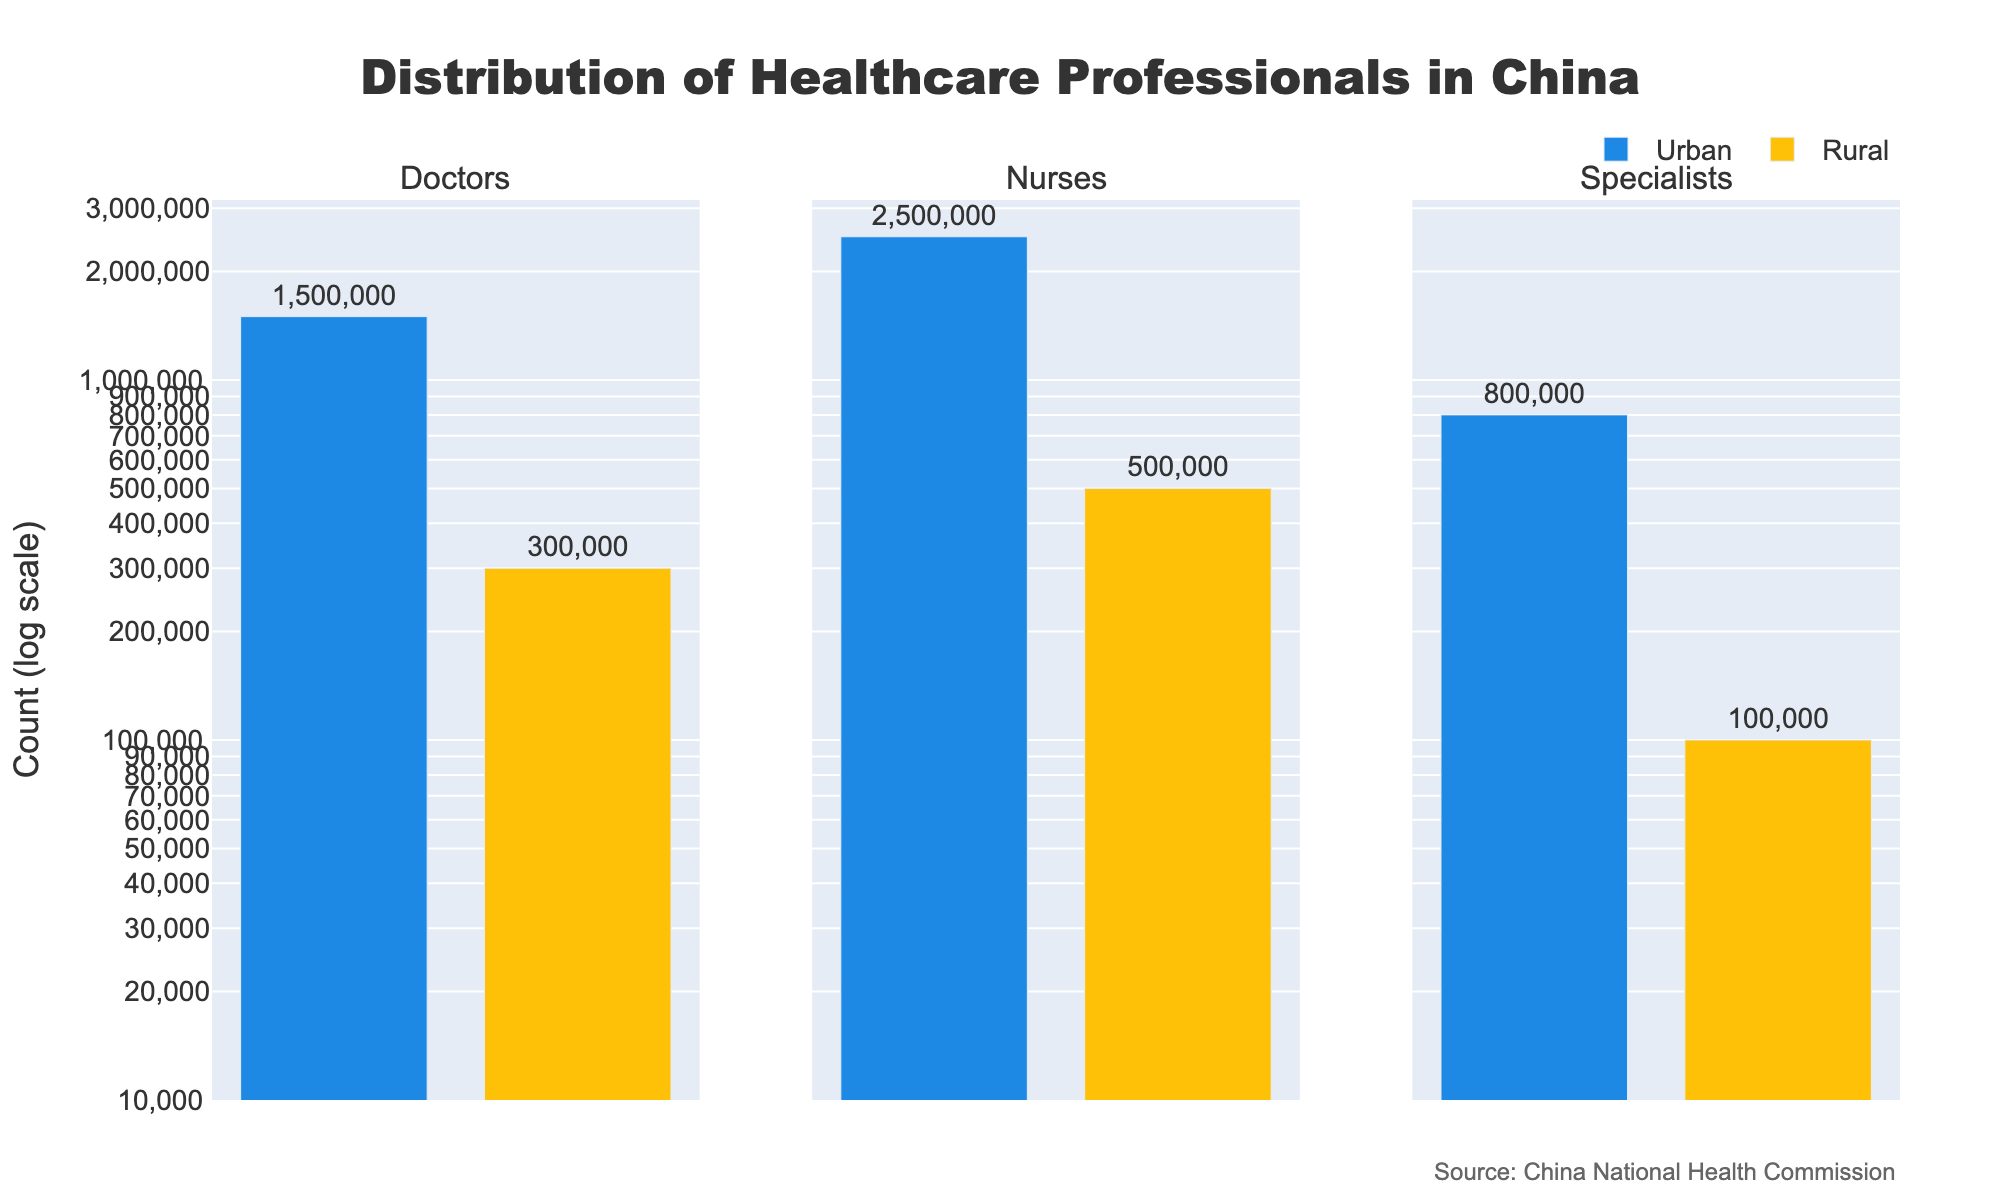What is the title of the figure? The title is typically located at the top of the figure. It provides a direct indication of the main subject of the plot. Here, the title states "Distribution of Healthcare Professionals in China."
Answer: Distribution of Healthcare Professionals in China What are the three subplots representing in the figure? Each subplot title indicates a different category of healthcare professionals: Doctors, Nurses, and Specialists. These titles are directly shown at the top of each subplot.
Answer: Doctors, Nurses, Specialists Which location (urban or rural) has a higher count of doctors? In the subplot for "Doctors," the bar representing urban areas is significantly taller than the bar for rural areas, indicating a higher count in urban locations.
Answer: Urban What is the total count of healthcare professionals (doctors, nurses, and specialists) in rural areas? Calculate the sum of counts for rural areas from each subplot: Doctors (300,000) + Nurses (500,000) + Specialists (100,000).
Answer: 900,000 How many healthcare professionals are in urban areas compared to rural areas for each category? Compare the counts from each subplot:
- Doctors: Urban (1,500,000) vs. Rural (300,000)
- Nurses: Urban (2,500,000) vs. Rural (500,000)
- Specialists: Urban (800,000) vs. Rural (100,000).
Answer: Urban has higher counts in all categories What is the ratio of urban to rural nurses? Divide the count of nurses in urban areas by the count in rural areas: 2,500,000 / 500,000 = 5. This means there are 5 times more nurses in urban areas compared to rural areas.
Answer: 5 Which type of healthcare professional shows the largest absolute difference in count between urban and rural areas? Calculate the absolute differences for each category:
- Doctors: 1,500,000 - 300,000 = 1,200,000
- Nurses: 2,500,000 - 500,000 = 2,000,000
- Specialists: 800,000 - 100,000 = 700,000
Nurses have the largest difference.
Answer: Nurses What is the count of the healthcare professional category with the smallest count in rural areas? In the subplots, the smallest bar for rural areas is for Specialists, which has a count of 100,000.
Answer: 100,000 Which healthcare professional category exhibits the highest count in any of the given areas? In the urban subplot, the bar for Nurses is the tallest with a count of 2,500,000, making it the highest count overall.
Answer: Nurses in Urban 